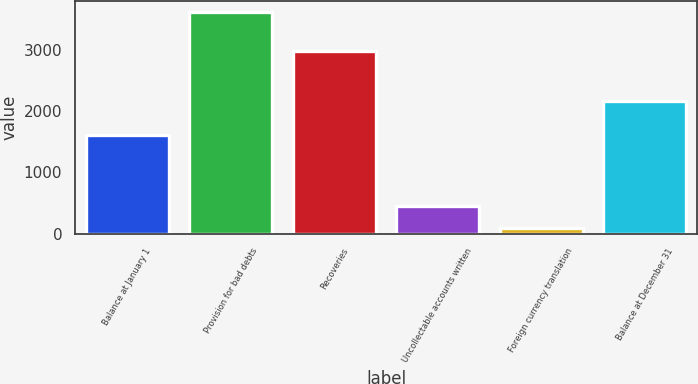Convert chart to OTSL. <chart><loc_0><loc_0><loc_500><loc_500><bar_chart><fcel>Balance at January 1<fcel>Provision for bad debts<fcel>Recoveries<fcel>Uncollectable accounts written<fcel>Foreign currency translation<fcel>Balance at December 31<nl><fcel>1605<fcel>3623<fcel>2981<fcel>448.7<fcel>96<fcel>2173<nl></chart> 